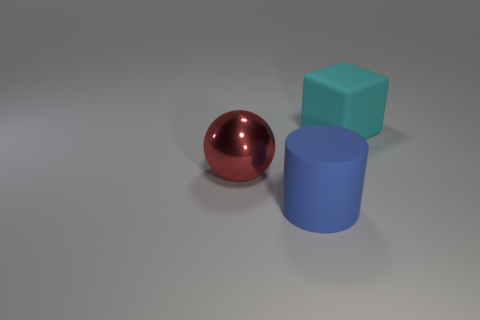Add 1 yellow spheres. How many objects exist? 4 Subtract all cylinders. How many objects are left? 2 Add 3 big red metallic objects. How many big red metallic objects are left? 4 Add 2 small blue metallic objects. How many small blue metallic objects exist? 2 Subtract 0 purple balls. How many objects are left? 3 Subtract all cyan matte things. Subtract all large blue cylinders. How many objects are left? 1 